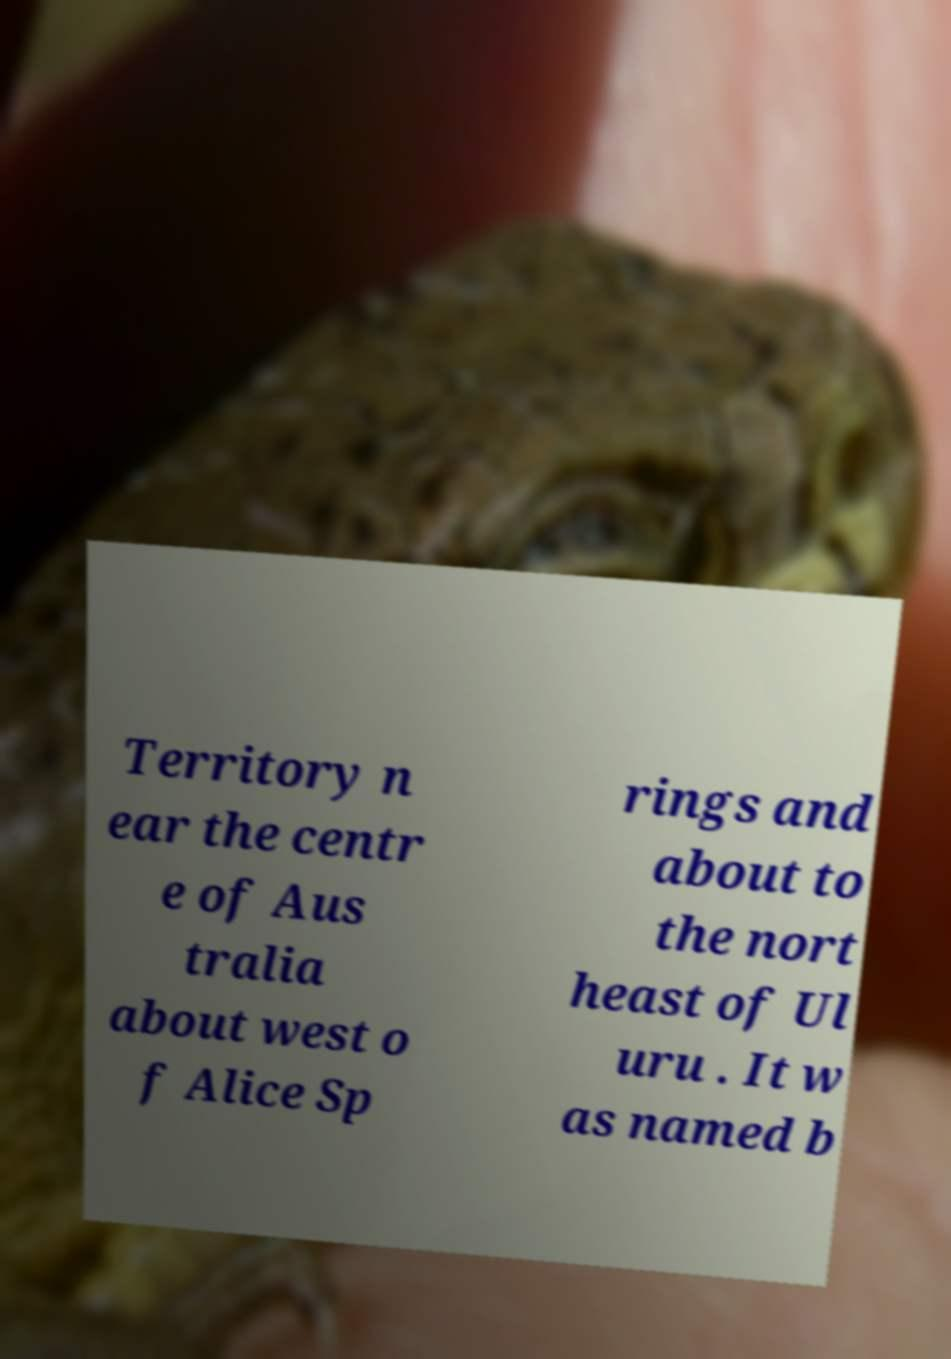Could you extract and type out the text from this image? Territory n ear the centr e of Aus tralia about west o f Alice Sp rings and about to the nort heast of Ul uru . It w as named b 